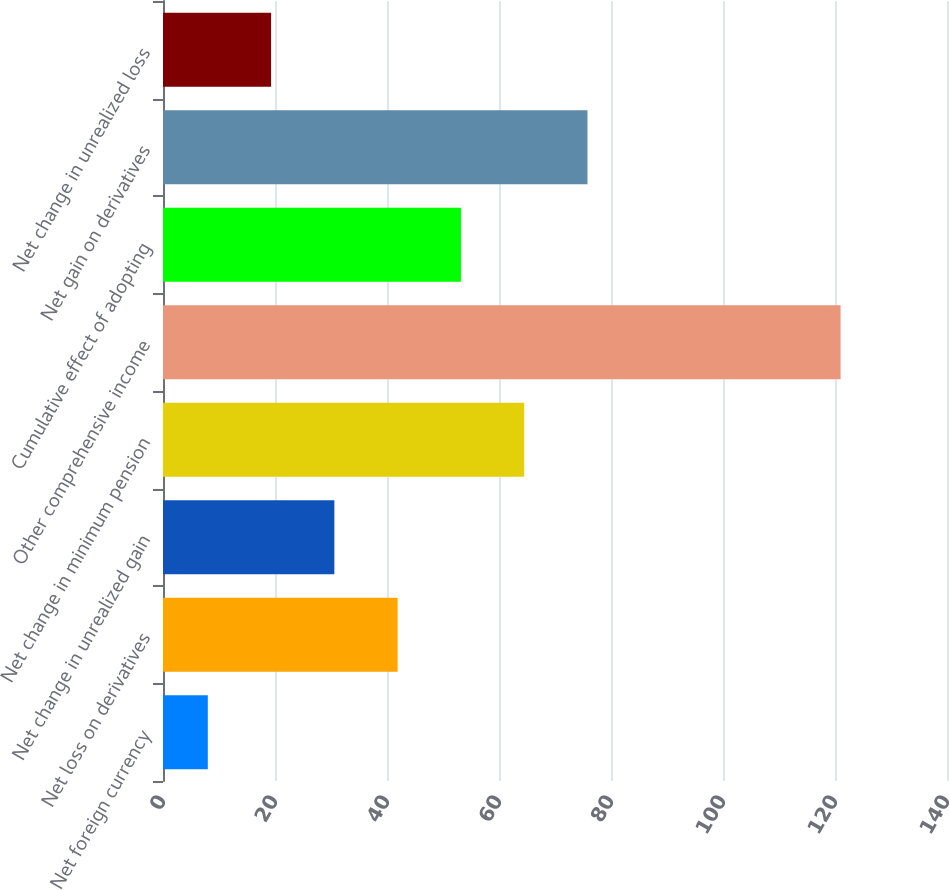Convert chart. <chart><loc_0><loc_0><loc_500><loc_500><bar_chart><fcel>Net foreign currency<fcel>Net loss on derivatives<fcel>Net change in unrealized gain<fcel>Net change in minimum pension<fcel>Other comprehensive income<fcel>Cumulative effect of adopting<fcel>Net gain on derivatives<fcel>Net change in unrealized loss<nl><fcel>8<fcel>41.9<fcel>30.6<fcel>64.5<fcel>121<fcel>53.2<fcel>75.8<fcel>19.3<nl></chart> 